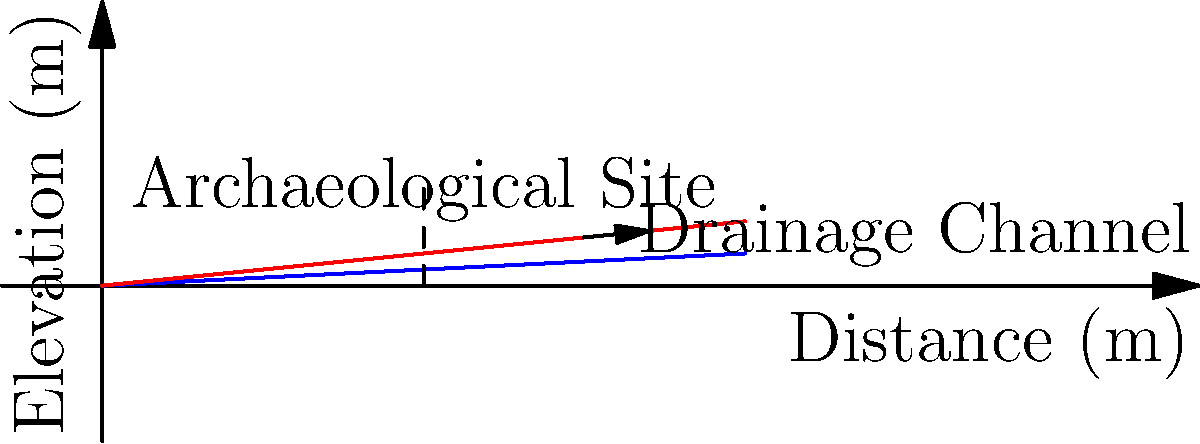In Komotini, an archaeological site requires protection from water damage. If the site is 10 meters long and the recommended minimum slope for proper drainage is 5%, what is the minimum elevation difference (in meters) needed between the highest and lowest points of the drainage system? Additionally, how would this change if the slope were increased to 10% to account for heavy rainfall common in the region? To solve this problem, we'll use the slope formula and calculate the elevation difference for both scenarios:

1. For a 5% slope:
   - Slope is rise over run: $\text{Slope} = \frac{\text{Rise}}{\text{Run}} = 0.05$
   - We know the run (length) is 10 meters
   - Let's solve for the rise (elevation difference):
     $0.05 = \frac{\text{Rise}}{10 \text{ m}}$
     $\text{Rise} = 0.05 \times 10 \text{ m} = 0.5 \text{ m}$

2. For a 10% slope:
   - Slope = $\frac{\text{Rise}}{\text{Run}} = 0.10$
   - Run is still 10 meters
   - Solving for rise:
     $0.10 = \frac{\text{Rise}}{10 \text{ m}}$
     $\text{Rise} = 0.10 \times 10 \text{ m} = 1.0 \text{ m}$

The minimum elevation difference for a 5% slope is 0.5 meters, and for a 10% slope, it's 1.0 meters.

The increased slope of 10% would provide better drainage during heavy rainfall, which is common in Komotini's climate. This steeper slope would help prevent water accumulation near the archaeological site, reducing the risk of water damage and erosion.
Answer: 5% slope: 0.5 m; 10% slope: 1.0 m 